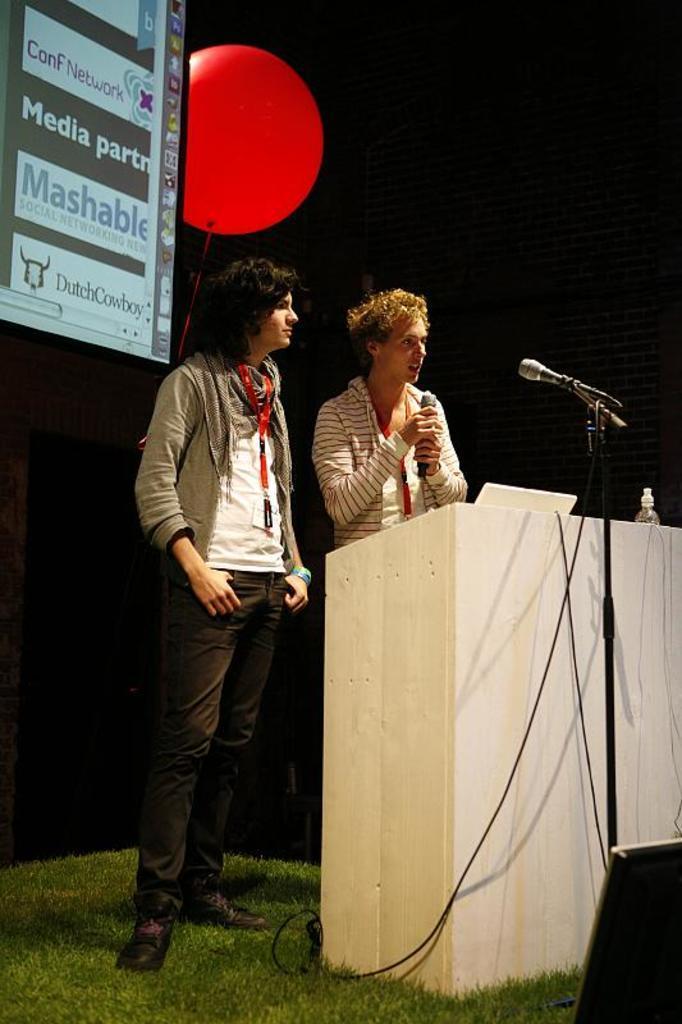Describe this image in one or two sentences. This picture might be taken inside a conference hall. In this image, in the middle, we can see two men. One man is holding a microphone in his hand and other man is standing on the grass. These two mens are standing in front of a podium, on that podium, we can see a laptop and a bottle. On the right side, we can also see a microphone and speakers. On the left side, there is a screen and red color balloon. In the background, we can see black color. 